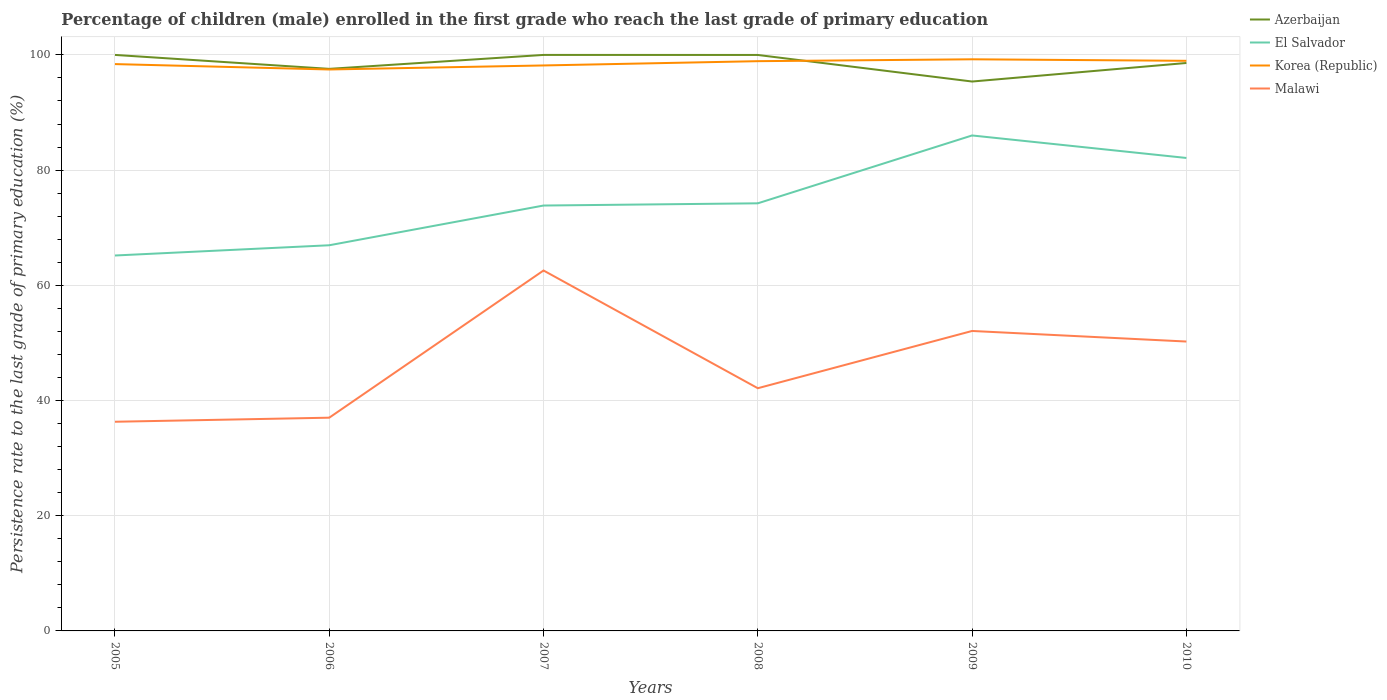How many different coloured lines are there?
Your answer should be very brief. 4. Does the line corresponding to El Salvador intersect with the line corresponding to Azerbaijan?
Provide a short and direct response. No. Across all years, what is the maximum persistence rate of children in El Salvador?
Your answer should be compact. 65.18. What is the total persistence rate of children in El Salvador in the graph?
Your response must be concise. -11.78. What is the difference between the highest and the second highest persistence rate of children in El Salvador?
Offer a very short reply. 20.84. Is the persistence rate of children in Korea (Republic) strictly greater than the persistence rate of children in Azerbaijan over the years?
Your answer should be compact. No. How many years are there in the graph?
Your response must be concise. 6. Are the values on the major ticks of Y-axis written in scientific E-notation?
Offer a terse response. No. Where does the legend appear in the graph?
Offer a very short reply. Top right. What is the title of the graph?
Provide a succinct answer. Percentage of children (male) enrolled in the first grade who reach the last grade of primary education. Does "Europe(all income levels)" appear as one of the legend labels in the graph?
Provide a short and direct response. No. What is the label or title of the Y-axis?
Provide a succinct answer. Persistence rate to the last grade of primary education (%). What is the Persistence rate to the last grade of primary education (%) in El Salvador in 2005?
Make the answer very short. 65.18. What is the Persistence rate to the last grade of primary education (%) of Korea (Republic) in 2005?
Offer a very short reply. 98.41. What is the Persistence rate to the last grade of primary education (%) in Malawi in 2005?
Offer a terse response. 36.31. What is the Persistence rate to the last grade of primary education (%) of Azerbaijan in 2006?
Your response must be concise. 97.58. What is the Persistence rate to the last grade of primary education (%) in El Salvador in 2006?
Give a very brief answer. 66.96. What is the Persistence rate to the last grade of primary education (%) in Korea (Republic) in 2006?
Offer a terse response. 97.47. What is the Persistence rate to the last grade of primary education (%) of Malawi in 2006?
Give a very brief answer. 37.02. What is the Persistence rate to the last grade of primary education (%) in Azerbaijan in 2007?
Provide a succinct answer. 100. What is the Persistence rate to the last grade of primary education (%) of El Salvador in 2007?
Ensure brevity in your answer.  73.85. What is the Persistence rate to the last grade of primary education (%) in Korea (Republic) in 2007?
Keep it short and to the point. 98.17. What is the Persistence rate to the last grade of primary education (%) in Malawi in 2007?
Provide a short and direct response. 62.57. What is the Persistence rate to the last grade of primary education (%) in Azerbaijan in 2008?
Give a very brief answer. 99.99. What is the Persistence rate to the last grade of primary education (%) of El Salvador in 2008?
Your answer should be compact. 74.24. What is the Persistence rate to the last grade of primary education (%) of Korea (Republic) in 2008?
Ensure brevity in your answer.  98.91. What is the Persistence rate to the last grade of primary education (%) in Malawi in 2008?
Make the answer very short. 42.13. What is the Persistence rate to the last grade of primary education (%) in Azerbaijan in 2009?
Your answer should be very brief. 95.38. What is the Persistence rate to the last grade of primary education (%) of El Salvador in 2009?
Give a very brief answer. 86.02. What is the Persistence rate to the last grade of primary education (%) of Korea (Republic) in 2009?
Provide a succinct answer. 99.24. What is the Persistence rate to the last grade of primary education (%) of Malawi in 2009?
Offer a very short reply. 52.08. What is the Persistence rate to the last grade of primary education (%) in Azerbaijan in 2010?
Offer a terse response. 98.6. What is the Persistence rate to the last grade of primary education (%) in El Salvador in 2010?
Your response must be concise. 82.11. What is the Persistence rate to the last grade of primary education (%) in Korea (Republic) in 2010?
Your response must be concise. 98.98. What is the Persistence rate to the last grade of primary education (%) of Malawi in 2010?
Provide a succinct answer. 50.24. Across all years, what is the maximum Persistence rate to the last grade of primary education (%) of Azerbaijan?
Your answer should be very brief. 100. Across all years, what is the maximum Persistence rate to the last grade of primary education (%) in El Salvador?
Ensure brevity in your answer.  86.02. Across all years, what is the maximum Persistence rate to the last grade of primary education (%) of Korea (Republic)?
Provide a short and direct response. 99.24. Across all years, what is the maximum Persistence rate to the last grade of primary education (%) in Malawi?
Keep it short and to the point. 62.57. Across all years, what is the minimum Persistence rate to the last grade of primary education (%) of Azerbaijan?
Ensure brevity in your answer.  95.38. Across all years, what is the minimum Persistence rate to the last grade of primary education (%) of El Salvador?
Make the answer very short. 65.18. Across all years, what is the minimum Persistence rate to the last grade of primary education (%) of Korea (Republic)?
Your answer should be very brief. 97.47. Across all years, what is the minimum Persistence rate to the last grade of primary education (%) in Malawi?
Give a very brief answer. 36.31. What is the total Persistence rate to the last grade of primary education (%) of Azerbaijan in the graph?
Your answer should be compact. 591.55. What is the total Persistence rate to the last grade of primary education (%) of El Salvador in the graph?
Your answer should be compact. 448.35. What is the total Persistence rate to the last grade of primary education (%) in Korea (Republic) in the graph?
Offer a terse response. 591.18. What is the total Persistence rate to the last grade of primary education (%) of Malawi in the graph?
Your answer should be compact. 280.36. What is the difference between the Persistence rate to the last grade of primary education (%) of Azerbaijan in 2005 and that in 2006?
Make the answer very short. 2.42. What is the difference between the Persistence rate to the last grade of primary education (%) in El Salvador in 2005 and that in 2006?
Keep it short and to the point. -1.78. What is the difference between the Persistence rate to the last grade of primary education (%) in Korea (Republic) in 2005 and that in 2006?
Make the answer very short. 0.94. What is the difference between the Persistence rate to the last grade of primary education (%) of Malawi in 2005 and that in 2006?
Your response must be concise. -0.71. What is the difference between the Persistence rate to the last grade of primary education (%) of Azerbaijan in 2005 and that in 2007?
Keep it short and to the point. 0. What is the difference between the Persistence rate to the last grade of primary education (%) of El Salvador in 2005 and that in 2007?
Give a very brief answer. -8.68. What is the difference between the Persistence rate to the last grade of primary education (%) of Korea (Republic) in 2005 and that in 2007?
Keep it short and to the point. 0.24. What is the difference between the Persistence rate to the last grade of primary education (%) of Malawi in 2005 and that in 2007?
Offer a very short reply. -26.26. What is the difference between the Persistence rate to the last grade of primary education (%) in Azerbaijan in 2005 and that in 2008?
Your response must be concise. 0.01. What is the difference between the Persistence rate to the last grade of primary education (%) of El Salvador in 2005 and that in 2008?
Give a very brief answer. -9.06. What is the difference between the Persistence rate to the last grade of primary education (%) of Korea (Republic) in 2005 and that in 2008?
Your answer should be very brief. -0.51. What is the difference between the Persistence rate to the last grade of primary education (%) in Malawi in 2005 and that in 2008?
Ensure brevity in your answer.  -5.82. What is the difference between the Persistence rate to the last grade of primary education (%) in Azerbaijan in 2005 and that in 2009?
Your answer should be very brief. 4.62. What is the difference between the Persistence rate to the last grade of primary education (%) of El Salvador in 2005 and that in 2009?
Offer a very short reply. -20.84. What is the difference between the Persistence rate to the last grade of primary education (%) in Korea (Republic) in 2005 and that in 2009?
Provide a short and direct response. -0.83. What is the difference between the Persistence rate to the last grade of primary education (%) in Malawi in 2005 and that in 2009?
Offer a very short reply. -15.76. What is the difference between the Persistence rate to the last grade of primary education (%) in Azerbaijan in 2005 and that in 2010?
Keep it short and to the point. 1.4. What is the difference between the Persistence rate to the last grade of primary education (%) of El Salvador in 2005 and that in 2010?
Provide a short and direct response. -16.93. What is the difference between the Persistence rate to the last grade of primary education (%) in Korea (Republic) in 2005 and that in 2010?
Offer a terse response. -0.57. What is the difference between the Persistence rate to the last grade of primary education (%) in Malawi in 2005 and that in 2010?
Ensure brevity in your answer.  -13.93. What is the difference between the Persistence rate to the last grade of primary education (%) in Azerbaijan in 2006 and that in 2007?
Your response must be concise. -2.42. What is the difference between the Persistence rate to the last grade of primary education (%) of El Salvador in 2006 and that in 2007?
Offer a terse response. -6.9. What is the difference between the Persistence rate to the last grade of primary education (%) of Korea (Republic) in 2006 and that in 2007?
Your response must be concise. -0.7. What is the difference between the Persistence rate to the last grade of primary education (%) of Malawi in 2006 and that in 2007?
Keep it short and to the point. -25.55. What is the difference between the Persistence rate to the last grade of primary education (%) of Azerbaijan in 2006 and that in 2008?
Your response must be concise. -2.41. What is the difference between the Persistence rate to the last grade of primary education (%) in El Salvador in 2006 and that in 2008?
Offer a terse response. -7.28. What is the difference between the Persistence rate to the last grade of primary education (%) of Korea (Republic) in 2006 and that in 2008?
Give a very brief answer. -1.44. What is the difference between the Persistence rate to the last grade of primary education (%) in Malawi in 2006 and that in 2008?
Keep it short and to the point. -5.11. What is the difference between the Persistence rate to the last grade of primary education (%) in El Salvador in 2006 and that in 2009?
Make the answer very short. -19.06. What is the difference between the Persistence rate to the last grade of primary education (%) of Korea (Republic) in 2006 and that in 2009?
Give a very brief answer. -1.77. What is the difference between the Persistence rate to the last grade of primary education (%) in Malawi in 2006 and that in 2009?
Make the answer very short. -15.06. What is the difference between the Persistence rate to the last grade of primary education (%) of Azerbaijan in 2006 and that in 2010?
Your response must be concise. -1.02. What is the difference between the Persistence rate to the last grade of primary education (%) of El Salvador in 2006 and that in 2010?
Provide a succinct answer. -15.16. What is the difference between the Persistence rate to the last grade of primary education (%) of Korea (Republic) in 2006 and that in 2010?
Keep it short and to the point. -1.5. What is the difference between the Persistence rate to the last grade of primary education (%) of Malawi in 2006 and that in 2010?
Provide a succinct answer. -13.22. What is the difference between the Persistence rate to the last grade of primary education (%) in Azerbaijan in 2007 and that in 2008?
Offer a terse response. 0.01. What is the difference between the Persistence rate to the last grade of primary education (%) of El Salvador in 2007 and that in 2008?
Provide a short and direct response. -0.38. What is the difference between the Persistence rate to the last grade of primary education (%) of Korea (Republic) in 2007 and that in 2008?
Ensure brevity in your answer.  -0.74. What is the difference between the Persistence rate to the last grade of primary education (%) of Malawi in 2007 and that in 2008?
Make the answer very short. 20.44. What is the difference between the Persistence rate to the last grade of primary education (%) in Azerbaijan in 2007 and that in 2009?
Ensure brevity in your answer.  4.62. What is the difference between the Persistence rate to the last grade of primary education (%) of El Salvador in 2007 and that in 2009?
Offer a very short reply. -12.16. What is the difference between the Persistence rate to the last grade of primary education (%) in Korea (Republic) in 2007 and that in 2009?
Your answer should be compact. -1.07. What is the difference between the Persistence rate to the last grade of primary education (%) of Malawi in 2007 and that in 2009?
Your answer should be very brief. 10.5. What is the difference between the Persistence rate to the last grade of primary education (%) of Azerbaijan in 2007 and that in 2010?
Your answer should be compact. 1.4. What is the difference between the Persistence rate to the last grade of primary education (%) in El Salvador in 2007 and that in 2010?
Provide a succinct answer. -8.26. What is the difference between the Persistence rate to the last grade of primary education (%) in Korea (Republic) in 2007 and that in 2010?
Make the answer very short. -0.81. What is the difference between the Persistence rate to the last grade of primary education (%) in Malawi in 2007 and that in 2010?
Provide a short and direct response. 12.33. What is the difference between the Persistence rate to the last grade of primary education (%) in Azerbaijan in 2008 and that in 2009?
Ensure brevity in your answer.  4.61. What is the difference between the Persistence rate to the last grade of primary education (%) of El Salvador in 2008 and that in 2009?
Your response must be concise. -11.78. What is the difference between the Persistence rate to the last grade of primary education (%) of Korea (Republic) in 2008 and that in 2009?
Your answer should be compact. -0.33. What is the difference between the Persistence rate to the last grade of primary education (%) in Malawi in 2008 and that in 2009?
Make the answer very short. -9.94. What is the difference between the Persistence rate to the last grade of primary education (%) in Azerbaijan in 2008 and that in 2010?
Provide a succinct answer. 1.39. What is the difference between the Persistence rate to the last grade of primary education (%) of El Salvador in 2008 and that in 2010?
Provide a succinct answer. -7.87. What is the difference between the Persistence rate to the last grade of primary education (%) of Korea (Republic) in 2008 and that in 2010?
Provide a short and direct response. -0.06. What is the difference between the Persistence rate to the last grade of primary education (%) of Malawi in 2008 and that in 2010?
Offer a terse response. -8.11. What is the difference between the Persistence rate to the last grade of primary education (%) in Azerbaijan in 2009 and that in 2010?
Make the answer very short. -3.22. What is the difference between the Persistence rate to the last grade of primary education (%) in El Salvador in 2009 and that in 2010?
Your answer should be compact. 3.91. What is the difference between the Persistence rate to the last grade of primary education (%) in Korea (Republic) in 2009 and that in 2010?
Provide a short and direct response. 0.26. What is the difference between the Persistence rate to the last grade of primary education (%) of Malawi in 2009 and that in 2010?
Provide a short and direct response. 1.84. What is the difference between the Persistence rate to the last grade of primary education (%) in Azerbaijan in 2005 and the Persistence rate to the last grade of primary education (%) in El Salvador in 2006?
Ensure brevity in your answer.  33.04. What is the difference between the Persistence rate to the last grade of primary education (%) in Azerbaijan in 2005 and the Persistence rate to the last grade of primary education (%) in Korea (Republic) in 2006?
Your answer should be very brief. 2.53. What is the difference between the Persistence rate to the last grade of primary education (%) of Azerbaijan in 2005 and the Persistence rate to the last grade of primary education (%) of Malawi in 2006?
Offer a very short reply. 62.98. What is the difference between the Persistence rate to the last grade of primary education (%) of El Salvador in 2005 and the Persistence rate to the last grade of primary education (%) of Korea (Republic) in 2006?
Keep it short and to the point. -32.3. What is the difference between the Persistence rate to the last grade of primary education (%) of El Salvador in 2005 and the Persistence rate to the last grade of primary education (%) of Malawi in 2006?
Provide a short and direct response. 28.16. What is the difference between the Persistence rate to the last grade of primary education (%) of Korea (Republic) in 2005 and the Persistence rate to the last grade of primary education (%) of Malawi in 2006?
Your answer should be compact. 61.39. What is the difference between the Persistence rate to the last grade of primary education (%) of Azerbaijan in 2005 and the Persistence rate to the last grade of primary education (%) of El Salvador in 2007?
Your answer should be compact. 26.15. What is the difference between the Persistence rate to the last grade of primary education (%) of Azerbaijan in 2005 and the Persistence rate to the last grade of primary education (%) of Korea (Republic) in 2007?
Ensure brevity in your answer.  1.83. What is the difference between the Persistence rate to the last grade of primary education (%) of Azerbaijan in 2005 and the Persistence rate to the last grade of primary education (%) of Malawi in 2007?
Offer a very short reply. 37.43. What is the difference between the Persistence rate to the last grade of primary education (%) in El Salvador in 2005 and the Persistence rate to the last grade of primary education (%) in Korea (Republic) in 2007?
Provide a short and direct response. -32.99. What is the difference between the Persistence rate to the last grade of primary education (%) in El Salvador in 2005 and the Persistence rate to the last grade of primary education (%) in Malawi in 2007?
Offer a very short reply. 2.6. What is the difference between the Persistence rate to the last grade of primary education (%) in Korea (Republic) in 2005 and the Persistence rate to the last grade of primary education (%) in Malawi in 2007?
Keep it short and to the point. 35.84. What is the difference between the Persistence rate to the last grade of primary education (%) of Azerbaijan in 2005 and the Persistence rate to the last grade of primary education (%) of El Salvador in 2008?
Your answer should be very brief. 25.76. What is the difference between the Persistence rate to the last grade of primary education (%) in Azerbaijan in 2005 and the Persistence rate to the last grade of primary education (%) in Korea (Republic) in 2008?
Your answer should be very brief. 1.09. What is the difference between the Persistence rate to the last grade of primary education (%) in Azerbaijan in 2005 and the Persistence rate to the last grade of primary education (%) in Malawi in 2008?
Your answer should be very brief. 57.87. What is the difference between the Persistence rate to the last grade of primary education (%) in El Salvador in 2005 and the Persistence rate to the last grade of primary education (%) in Korea (Republic) in 2008?
Give a very brief answer. -33.74. What is the difference between the Persistence rate to the last grade of primary education (%) of El Salvador in 2005 and the Persistence rate to the last grade of primary education (%) of Malawi in 2008?
Make the answer very short. 23.04. What is the difference between the Persistence rate to the last grade of primary education (%) of Korea (Republic) in 2005 and the Persistence rate to the last grade of primary education (%) of Malawi in 2008?
Make the answer very short. 56.27. What is the difference between the Persistence rate to the last grade of primary education (%) of Azerbaijan in 2005 and the Persistence rate to the last grade of primary education (%) of El Salvador in 2009?
Give a very brief answer. 13.98. What is the difference between the Persistence rate to the last grade of primary education (%) of Azerbaijan in 2005 and the Persistence rate to the last grade of primary education (%) of Korea (Republic) in 2009?
Your answer should be compact. 0.76. What is the difference between the Persistence rate to the last grade of primary education (%) of Azerbaijan in 2005 and the Persistence rate to the last grade of primary education (%) of Malawi in 2009?
Provide a short and direct response. 47.92. What is the difference between the Persistence rate to the last grade of primary education (%) in El Salvador in 2005 and the Persistence rate to the last grade of primary education (%) in Korea (Republic) in 2009?
Your answer should be very brief. -34.06. What is the difference between the Persistence rate to the last grade of primary education (%) of El Salvador in 2005 and the Persistence rate to the last grade of primary education (%) of Malawi in 2009?
Your answer should be very brief. 13.1. What is the difference between the Persistence rate to the last grade of primary education (%) in Korea (Republic) in 2005 and the Persistence rate to the last grade of primary education (%) in Malawi in 2009?
Your answer should be compact. 46.33. What is the difference between the Persistence rate to the last grade of primary education (%) in Azerbaijan in 2005 and the Persistence rate to the last grade of primary education (%) in El Salvador in 2010?
Your answer should be very brief. 17.89. What is the difference between the Persistence rate to the last grade of primary education (%) of Azerbaijan in 2005 and the Persistence rate to the last grade of primary education (%) of Korea (Republic) in 2010?
Your response must be concise. 1.02. What is the difference between the Persistence rate to the last grade of primary education (%) of Azerbaijan in 2005 and the Persistence rate to the last grade of primary education (%) of Malawi in 2010?
Your answer should be compact. 49.76. What is the difference between the Persistence rate to the last grade of primary education (%) of El Salvador in 2005 and the Persistence rate to the last grade of primary education (%) of Korea (Republic) in 2010?
Provide a succinct answer. -33.8. What is the difference between the Persistence rate to the last grade of primary education (%) of El Salvador in 2005 and the Persistence rate to the last grade of primary education (%) of Malawi in 2010?
Your response must be concise. 14.94. What is the difference between the Persistence rate to the last grade of primary education (%) in Korea (Republic) in 2005 and the Persistence rate to the last grade of primary education (%) in Malawi in 2010?
Offer a terse response. 48.17. What is the difference between the Persistence rate to the last grade of primary education (%) of Azerbaijan in 2006 and the Persistence rate to the last grade of primary education (%) of El Salvador in 2007?
Give a very brief answer. 23.73. What is the difference between the Persistence rate to the last grade of primary education (%) of Azerbaijan in 2006 and the Persistence rate to the last grade of primary education (%) of Korea (Republic) in 2007?
Provide a short and direct response. -0.59. What is the difference between the Persistence rate to the last grade of primary education (%) in Azerbaijan in 2006 and the Persistence rate to the last grade of primary education (%) in Malawi in 2007?
Ensure brevity in your answer.  35.01. What is the difference between the Persistence rate to the last grade of primary education (%) in El Salvador in 2006 and the Persistence rate to the last grade of primary education (%) in Korea (Republic) in 2007?
Offer a very short reply. -31.22. What is the difference between the Persistence rate to the last grade of primary education (%) of El Salvador in 2006 and the Persistence rate to the last grade of primary education (%) of Malawi in 2007?
Ensure brevity in your answer.  4.38. What is the difference between the Persistence rate to the last grade of primary education (%) in Korea (Republic) in 2006 and the Persistence rate to the last grade of primary education (%) in Malawi in 2007?
Your answer should be compact. 34.9. What is the difference between the Persistence rate to the last grade of primary education (%) of Azerbaijan in 2006 and the Persistence rate to the last grade of primary education (%) of El Salvador in 2008?
Keep it short and to the point. 23.34. What is the difference between the Persistence rate to the last grade of primary education (%) in Azerbaijan in 2006 and the Persistence rate to the last grade of primary education (%) in Korea (Republic) in 2008?
Your answer should be compact. -1.33. What is the difference between the Persistence rate to the last grade of primary education (%) in Azerbaijan in 2006 and the Persistence rate to the last grade of primary education (%) in Malawi in 2008?
Provide a succinct answer. 55.45. What is the difference between the Persistence rate to the last grade of primary education (%) in El Salvador in 2006 and the Persistence rate to the last grade of primary education (%) in Korea (Republic) in 2008?
Your answer should be compact. -31.96. What is the difference between the Persistence rate to the last grade of primary education (%) in El Salvador in 2006 and the Persistence rate to the last grade of primary education (%) in Malawi in 2008?
Offer a very short reply. 24.82. What is the difference between the Persistence rate to the last grade of primary education (%) in Korea (Republic) in 2006 and the Persistence rate to the last grade of primary education (%) in Malawi in 2008?
Your response must be concise. 55.34. What is the difference between the Persistence rate to the last grade of primary education (%) of Azerbaijan in 2006 and the Persistence rate to the last grade of primary education (%) of El Salvador in 2009?
Ensure brevity in your answer.  11.56. What is the difference between the Persistence rate to the last grade of primary education (%) in Azerbaijan in 2006 and the Persistence rate to the last grade of primary education (%) in Korea (Republic) in 2009?
Your answer should be compact. -1.66. What is the difference between the Persistence rate to the last grade of primary education (%) of Azerbaijan in 2006 and the Persistence rate to the last grade of primary education (%) of Malawi in 2009?
Your answer should be compact. 45.5. What is the difference between the Persistence rate to the last grade of primary education (%) in El Salvador in 2006 and the Persistence rate to the last grade of primary education (%) in Korea (Republic) in 2009?
Give a very brief answer. -32.29. What is the difference between the Persistence rate to the last grade of primary education (%) of El Salvador in 2006 and the Persistence rate to the last grade of primary education (%) of Malawi in 2009?
Give a very brief answer. 14.88. What is the difference between the Persistence rate to the last grade of primary education (%) of Korea (Republic) in 2006 and the Persistence rate to the last grade of primary education (%) of Malawi in 2009?
Provide a short and direct response. 45.4. What is the difference between the Persistence rate to the last grade of primary education (%) in Azerbaijan in 2006 and the Persistence rate to the last grade of primary education (%) in El Salvador in 2010?
Offer a terse response. 15.47. What is the difference between the Persistence rate to the last grade of primary education (%) in Azerbaijan in 2006 and the Persistence rate to the last grade of primary education (%) in Korea (Republic) in 2010?
Ensure brevity in your answer.  -1.4. What is the difference between the Persistence rate to the last grade of primary education (%) of Azerbaijan in 2006 and the Persistence rate to the last grade of primary education (%) of Malawi in 2010?
Your answer should be compact. 47.34. What is the difference between the Persistence rate to the last grade of primary education (%) in El Salvador in 2006 and the Persistence rate to the last grade of primary education (%) in Korea (Republic) in 2010?
Keep it short and to the point. -32.02. What is the difference between the Persistence rate to the last grade of primary education (%) in El Salvador in 2006 and the Persistence rate to the last grade of primary education (%) in Malawi in 2010?
Keep it short and to the point. 16.72. What is the difference between the Persistence rate to the last grade of primary education (%) in Korea (Republic) in 2006 and the Persistence rate to the last grade of primary education (%) in Malawi in 2010?
Make the answer very short. 47.23. What is the difference between the Persistence rate to the last grade of primary education (%) of Azerbaijan in 2007 and the Persistence rate to the last grade of primary education (%) of El Salvador in 2008?
Offer a terse response. 25.76. What is the difference between the Persistence rate to the last grade of primary education (%) in Azerbaijan in 2007 and the Persistence rate to the last grade of primary education (%) in Korea (Republic) in 2008?
Make the answer very short. 1.09. What is the difference between the Persistence rate to the last grade of primary education (%) of Azerbaijan in 2007 and the Persistence rate to the last grade of primary education (%) of Malawi in 2008?
Keep it short and to the point. 57.87. What is the difference between the Persistence rate to the last grade of primary education (%) in El Salvador in 2007 and the Persistence rate to the last grade of primary education (%) in Korea (Republic) in 2008?
Your answer should be very brief. -25.06. What is the difference between the Persistence rate to the last grade of primary education (%) in El Salvador in 2007 and the Persistence rate to the last grade of primary education (%) in Malawi in 2008?
Provide a short and direct response. 31.72. What is the difference between the Persistence rate to the last grade of primary education (%) in Korea (Republic) in 2007 and the Persistence rate to the last grade of primary education (%) in Malawi in 2008?
Your answer should be very brief. 56.04. What is the difference between the Persistence rate to the last grade of primary education (%) of Azerbaijan in 2007 and the Persistence rate to the last grade of primary education (%) of El Salvador in 2009?
Offer a terse response. 13.98. What is the difference between the Persistence rate to the last grade of primary education (%) in Azerbaijan in 2007 and the Persistence rate to the last grade of primary education (%) in Korea (Republic) in 2009?
Offer a terse response. 0.76. What is the difference between the Persistence rate to the last grade of primary education (%) in Azerbaijan in 2007 and the Persistence rate to the last grade of primary education (%) in Malawi in 2009?
Your response must be concise. 47.92. What is the difference between the Persistence rate to the last grade of primary education (%) in El Salvador in 2007 and the Persistence rate to the last grade of primary education (%) in Korea (Republic) in 2009?
Give a very brief answer. -25.39. What is the difference between the Persistence rate to the last grade of primary education (%) in El Salvador in 2007 and the Persistence rate to the last grade of primary education (%) in Malawi in 2009?
Make the answer very short. 21.78. What is the difference between the Persistence rate to the last grade of primary education (%) in Korea (Republic) in 2007 and the Persistence rate to the last grade of primary education (%) in Malawi in 2009?
Make the answer very short. 46.1. What is the difference between the Persistence rate to the last grade of primary education (%) of Azerbaijan in 2007 and the Persistence rate to the last grade of primary education (%) of El Salvador in 2010?
Offer a very short reply. 17.89. What is the difference between the Persistence rate to the last grade of primary education (%) of Azerbaijan in 2007 and the Persistence rate to the last grade of primary education (%) of Korea (Republic) in 2010?
Keep it short and to the point. 1.02. What is the difference between the Persistence rate to the last grade of primary education (%) in Azerbaijan in 2007 and the Persistence rate to the last grade of primary education (%) in Malawi in 2010?
Your answer should be compact. 49.76. What is the difference between the Persistence rate to the last grade of primary education (%) of El Salvador in 2007 and the Persistence rate to the last grade of primary education (%) of Korea (Republic) in 2010?
Offer a very short reply. -25.12. What is the difference between the Persistence rate to the last grade of primary education (%) in El Salvador in 2007 and the Persistence rate to the last grade of primary education (%) in Malawi in 2010?
Your response must be concise. 23.61. What is the difference between the Persistence rate to the last grade of primary education (%) of Korea (Republic) in 2007 and the Persistence rate to the last grade of primary education (%) of Malawi in 2010?
Offer a terse response. 47.93. What is the difference between the Persistence rate to the last grade of primary education (%) of Azerbaijan in 2008 and the Persistence rate to the last grade of primary education (%) of El Salvador in 2009?
Give a very brief answer. 13.98. What is the difference between the Persistence rate to the last grade of primary education (%) of Azerbaijan in 2008 and the Persistence rate to the last grade of primary education (%) of Korea (Republic) in 2009?
Offer a very short reply. 0.75. What is the difference between the Persistence rate to the last grade of primary education (%) of Azerbaijan in 2008 and the Persistence rate to the last grade of primary education (%) of Malawi in 2009?
Keep it short and to the point. 47.92. What is the difference between the Persistence rate to the last grade of primary education (%) in El Salvador in 2008 and the Persistence rate to the last grade of primary education (%) in Korea (Republic) in 2009?
Your answer should be very brief. -25. What is the difference between the Persistence rate to the last grade of primary education (%) in El Salvador in 2008 and the Persistence rate to the last grade of primary education (%) in Malawi in 2009?
Give a very brief answer. 22.16. What is the difference between the Persistence rate to the last grade of primary education (%) of Korea (Republic) in 2008 and the Persistence rate to the last grade of primary education (%) of Malawi in 2009?
Your response must be concise. 46.84. What is the difference between the Persistence rate to the last grade of primary education (%) of Azerbaijan in 2008 and the Persistence rate to the last grade of primary education (%) of El Salvador in 2010?
Provide a succinct answer. 17.88. What is the difference between the Persistence rate to the last grade of primary education (%) of Azerbaijan in 2008 and the Persistence rate to the last grade of primary education (%) of Korea (Republic) in 2010?
Ensure brevity in your answer.  1.02. What is the difference between the Persistence rate to the last grade of primary education (%) of Azerbaijan in 2008 and the Persistence rate to the last grade of primary education (%) of Malawi in 2010?
Your response must be concise. 49.75. What is the difference between the Persistence rate to the last grade of primary education (%) of El Salvador in 2008 and the Persistence rate to the last grade of primary education (%) of Korea (Republic) in 2010?
Keep it short and to the point. -24.74. What is the difference between the Persistence rate to the last grade of primary education (%) in El Salvador in 2008 and the Persistence rate to the last grade of primary education (%) in Malawi in 2010?
Offer a terse response. 24. What is the difference between the Persistence rate to the last grade of primary education (%) of Korea (Republic) in 2008 and the Persistence rate to the last grade of primary education (%) of Malawi in 2010?
Your answer should be compact. 48.67. What is the difference between the Persistence rate to the last grade of primary education (%) of Azerbaijan in 2009 and the Persistence rate to the last grade of primary education (%) of El Salvador in 2010?
Your response must be concise. 13.27. What is the difference between the Persistence rate to the last grade of primary education (%) in Azerbaijan in 2009 and the Persistence rate to the last grade of primary education (%) in Korea (Republic) in 2010?
Your answer should be compact. -3.6. What is the difference between the Persistence rate to the last grade of primary education (%) in Azerbaijan in 2009 and the Persistence rate to the last grade of primary education (%) in Malawi in 2010?
Your answer should be compact. 45.14. What is the difference between the Persistence rate to the last grade of primary education (%) of El Salvador in 2009 and the Persistence rate to the last grade of primary education (%) of Korea (Republic) in 2010?
Give a very brief answer. -12.96. What is the difference between the Persistence rate to the last grade of primary education (%) of El Salvador in 2009 and the Persistence rate to the last grade of primary education (%) of Malawi in 2010?
Make the answer very short. 35.78. What is the difference between the Persistence rate to the last grade of primary education (%) of Korea (Republic) in 2009 and the Persistence rate to the last grade of primary education (%) of Malawi in 2010?
Provide a succinct answer. 49. What is the average Persistence rate to the last grade of primary education (%) of Azerbaijan per year?
Ensure brevity in your answer.  98.59. What is the average Persistence rate to the last grade of primary education (%) in El Salvador per year?
Give a very brief answer. 74.72. What is the average Persistence rate to the last grade of primary education (%) in Korea (Republic) per year?
Offer a terse response. 98.53. What is the average Persistence rate to the last grade of primary education (%) in Malawi per year?
Your answer should be compact. 46.73. In the year 2005, what is the difference between the Persistence rate to the last grade of primary education (%) in Azerbaijan and Persistence rate to the last grade of primary education (%) in El Salvador?
Your response must be concise. 34.82. In the year 2005, what is the difference between the Persistence rate to the last grade of primary education (%) of Azerbaijan and Persistence rate to the last grade of primary education (%) of Korea (Republic)?
Provide a succinct answer. 1.59. In the year 2005, what is the difference between the Persistence rate to the last grade of primary education (%) of Azerbaijan and Persistence rate to the last grade of primary education (%) of Malawi?
Provide a succinct answer. 63.69. In the year 2005, what is the difference between the Persistence rate to the last grade of primary education (%) of El Salvador and Persistence rate to the last grade of primary education (%) of Korea (Republic)?
Offer a terse response. -33.23. In the year 2005, what is the difference between the Persistence rate to the last grade of primary education (%) of El Salvador and Persistence rate to the last grade of primary education (%) of Malawi?
Your answer should be compact. 28.86. In the year 2005, what is the difference between the Persistence rate to the last grade of primary education (%) in Korea (Republic) and Persistence rate to the last grade of primary education (%) in Malawi?
Your response must be concise. 62.09. In the year 2006, what is the difference between the Persistence rate to the last grade of primary education (%) in Azerbaijan and Persistence rate to the last grade of primary education (%) in El Salvador?
Keep it short and to the point. 30.62. In the year 2006, what is the difference between the Persistence rate to the last grade of primary education (%) in Azerbaijan and Persistence rate to the last grade of primary education (%) in Korea (Republic)?
Give a very brief answer. 0.11. In the year 2006, what is the difference between the Persistence rate to the last grade of primary education (%) of Azerbaijan and Persistence rate to the last grade of primary education (%) of Malawi?
Ensure brevity in your answer.  60.56. In the year 2006, what is the difference between the Persistence rate to the last grade of primary education (%) of El Salvador and Persistence rate to the last grade of primary education (%) of Korea (Republic)?
Make the answer very short. -30.52. In the year 2006, what is the difference between the Persistence rate to the last grade of primary education (%) of El Salvador and Persistence rate to the last grade of primary education (%) of Malawi?
Your answer should be very brief. 29.94. In the year 2006, what is the difference between the Persistence rate to the last grade of primary education (%) of Korea (Republic) and Persistence rate to the last grade of primary education (%) of Malawi?
Your answer should be compact. 60.45. In the year 2007, what is the difference between the Persistence rate to the last grade of primary education (%) in Azerbaijan and Persistence rate to the last grade of primary education (%) in El Salvador?
Provide a short and direct response. 26.15. In the year 2007, what is the difference between the Persistence rate to the last grade of primary education (%) of Azerbaijan and Persistence rate to the last grade of primary education (%) of Korea (Republic)?
Provide a short and direct response. 1.83. In the year 2007, what is the difference between the Persistence rate to the last grade of primary education (%) of Azerbaijan and Persistence rate to the last grade of primary education (%) of Malawi?
Provide a short and direct response. 37.43. In the year 2007, what is the difference between the Persistence rate to the last grade of primary education (%) in El Salvador and Persistence rate to the last grade of primary education (%) in Korea (Republic)?
Your response must be concise. -24.32. In the year 2007, what is the difference between the Persistence rate to the last grade of primary education (%) of El Salvador and Persistence rate to the last grade of primary education (%) of Malawi?
Your response must be concise. 11.28. In the year 2007, what is the difference between the Persistence rate to the last grade of primary education (%) of Korea (Republic) and Persistence rate to the last grade of primary education (%) of Malawi?
Offer a very short reply. 35.6. In the year 2008, what is the difference between the Persistence rate to the last grade of primary education (%) in Azerbaijan and Persistence rate to the last grade of primary education (%) in El Salvador?
Make the answer very short. 25.76. In the year 2008, what is the difference between the Persistence rate to the last grade of primary education (%) in Azerbaijan and Persistence rate to the last grade of primary education (%) in Korea (Republic)?
Provide a short and direct response. 1.08. In the year 2008, what is the difference between the Persistence rate to the last grade of primary education (%) in Azerbaijan and Persistence rate to the last grade of primary education (%) in Malawi?
Provide a succinct answer. 57.86. In the year 2008, what is the difference between the Persistence rate to the last grade of primary education (%) in El Salvador and Persistence rate to the last grade of primary education (%) in Korea (Republic)?
Offer a terse response. -24.68. In the year 2008, what is the difference between the Persistence rate to the last grade of primary education (%) of El Salvador and Persistence rate to the last grade of primary education (%) of Malawi?
Offer a terse response. 32.1. In the year 2008, what is the difference between the Persistence rate to the last grade of primary education (%) in Korea (Republic) and Persistence rate to the last grade of primary education (%) in Malawi?
Ensure brevity in your answer.  56.78. In the year 2009, what is the difference between the Persistence rate to the last grade of primary education (%) in Azerbaijan and Persistence rate to the last grade of primary education (%) in El Salvador?
Make the answer very short. 9.36. In the year 2009, what is the difference between the Persistence rate to the last grade of primary education (%) in Azerbaijan and Persistence rate to the last grade of primary education (%) in Korea (Republic)?
Make the answer very short. -3.86. In the year 2009, what is the difference between the Persistence rate to the last grade of primary education (%) of Azerbaijan and Persistence rate to the last grade of primary education (%) of Malawi?
Offer a terse response. 43.3. In the year 2009, what is the difference between the Persistence rate to the last grade of primary education (%) in El Salvador and Persistence rate to the last grade of primary education (%) in Korea (Republic)?
Your response must be concise. -13.22. In the year 2009, what is the difference between the Persistence rate to the last grade of primary education (%) of El Salvador and Persistence rate to the last grade of primary education (%) of Malawi?
Your response must be concise. 33.94. In the year 2009, what is the difference between the Persistence rate to the last grade of primary education (%) of Korea (Republic) and Persistence rate to the last grade of primary education (%) of Malawi?
Your answer should be compact. 47.17. In the year 2010, what is the difference between the Persistence rate to the last grade of primary education (%) of Azerbaijan and Persistence rate to the last grade of primary education (%) of El Salvador?
Offer a terse response. 16.49. In the year 2010, what is the difference between the Persistence rate to the last grade of primary education (%) in Azerbaijan and Persistence rate to the last grade of primary education (%) in Korea (Republic)?
Offer a terse response. -0.38. In the year 2010, what is the difference between the Persistence rate to the last grade of primary education (%) of Azerbaijan and Persistence rate to the last grade of primary education (%) of Malawi?
Your answer should be compact. 48.36. In the year 2010, what is the difference between the Persistence rate to the last grade of primary education (%) in El Salvador and Persistence rate to the last grade of primary education (%) in Korea (Republic)?
Keep it short and to the point. -16.87. In the year 2010, what is the difference between the Persistence rate to the last grade of primary education (%) in El Salvador and Persistence rate to the last grade of primary education (%) in Malawi?
Offer a terse response. 31.87. In the year 2010, what is the difference between the Persistence rate to the last grade of primary education (%) of Korea (Republic) and Persistence rate to the last grade of primary education (%) of Malawi?
Offer a very short reply. 48.74. What is the ratio of the Persistence rate to the last grade of primary education (%) in Azerbaijan in 2005 to that in 2006?
Provide a short and direct response. 1.02. What is the ratio of the Persistence rate to the last grade of primary education (%) in El Salvador in 2005 to that in 2006?
Make the answer very short. 0.97. What is the ratio of the Persistence rate to the last grade of primary education (%) in Korea (Republic) in 2005 to that in 2006?
Your answer should be very brief. 1.01. What is the ratio of the Persistence rate to the last grade of primary education (%) in Malawi in 2005 to that in 2006?
Your answer should be very brief. 0.98. What is the ratio of the Persistence rate to the last grade of primary education (%) of El Salvador in 2005 to that in 2007?
Ensure brevity in your answer.  0.88. What is the ratio of the Persistence rate to the last grade of primary education (%) of Malawi in 2005 to that in 2007?
Your answer should be compact. 0.58. What is the ratio of the Persistence rate to the last grade of primary education (%) in Azerbaijan in 2005 to that in 2008?
Your answer should be compact. 1. What is the ratio of the Persistence rate to the last grade of primary education (%) in El Salvador in 2005 to that in 2008?
Provide a short and direct response. 0.88. What is the ratio of the Persistence rate to the last grade of primary education (%) in Malawi in 2005 to that in 2008?
Provide a short and direct response. 0.86. What is the ratio of the Persistence rate to the last grade of primary education (%) of Azerbaijan in 2005 to that in 2009?
Give a very brief answer. 1.05. What is the ratio of the Persistence rate to the last grade of primary education (%) in El Salvador in 2005 to that in 2009?
Your answer should be very brief. 0.76. What is the ratio of the Persistence rate to the last grade of primary education (%) in Malawi in 2005 to that in 2009?
Keep it short and to the point. 0.7. What is the ratio of the Persistence rate to the last grade of primary education (%) of Azerbaijan in 2005 to that in 2010?
Offer a very short reply. 1.01. What is the ratio of the Persistence rate to the last grade of primary education (%) in El Salvador in 2005 to that in 2010?
Your answer should be compact. 0.79. What is the ratio of the Persistence rate to the last grade of primary education (%) of Malawi in 2005 to that in 2010?
Keep it short and to the point. 0.72. What is the ratio of the Persistence rate to the last grade of primary education (%) in Azerbaijan in 2006 to that in 2007?
Give a very brief answer. 0.98. What is the ratio of the Persistence rate to the last grade of primary education (%) in El Salvador in 2006 to that in 2007?
Give a very brief answer. 0.91. What is the ratio of the Persistence rate to the last grade of primary education (%) in Korea (Republic) in 2006 to that in 2007?
Offer a terse response. 0.99. What is the ratio of the Persistence rate to the last grade of primary education (%) of Malawi in 2006 to that in 2007?
Your answer should be very brief. 0.59. What is the ratio of the Persistence rate to the last grade of primary education (%) of Azerbaijan in 2006 to that in 2008?
Your answer should be very brief. 0.98. What is the ratio of the Persistence rate to the last grade of primary education (%) in El Salvador in 2006 to that in 2008?
Your answer should be compact. 0.9. What is the ratio of the Persistence rate to the last grade of primary education (%) of Korea (Republic) in 2006 to that in 2008?
Provide a short and direct response. 0.99. What is the ratio of the Persistence rate to the last grade of primary education (%) in Malawi in 2006 to that in 2008?
Your response must be concise. 0.88. What is the ratio of the Persistence rate to the last grade of primary education (%) in Azerbaijan in 2006 to that in 2009?
Provide a short and direct response. 1.02. What is the ratio of the Persistence rate to the last grade of primary education (%) of El Salvador in 2006 to that in 2009?
Offer a very short reply. 0.78. What is the ratio of the Persistence rate to the last grade of primary education (%) in Korea (Republic) in 2006 to that in 2009?
Your response must be concise. 0.98. What is the ratio of the Persistence rate to the last grade of primary education (%) in Malawi in 2006 to that in 2009?
Your response must be concise. 0.71. What is the ratio of the Persistence rate to the last grade of primary education (%) in Azerbaijan in 2006 to that in 2010?
Keep it short and to the point. 0.99. What is the ratio of the Persistence rate to the last grade of primary education (%) in El Salvador in 2006 to that in 2010?
Your answer should be very brief. 0.82. What is the ratio of the Persistence rate to the last grade of primary education (%) in Korea (Republic) in 2006 to that in 2010?
Ensure brevity in your answer.  0.98. What is the ratio of the Persistence rate to the last grade of primary education (%) of Malawi in 2006 to that in 2010?
Keep it short and to the point. 0.74. What is the ratio of the Persistence rate to the last grade of primary education (%) in El Salvador in 2007 to that in 2008?
Provide a succinct answer. 0.99. What is the ratio of the Persistence rate to the last grade of primary education (%) in Malawi in 2007 to that in 2008?
Provide a short and direct response. 1.49. What is the ratio of the Persistence rate to the last grade of primary education (%) of Azerbaijan in 2007 to that in 2009?
Ensure brevity in your answer.  1.05. What is the ratio of the Persistence rate to the last grade of primary education (%) in El Salvador in 2007 to that in 2009?
Provide a short and direct response. 0.86. What is the ratio of the Persistence rate to the last grade of primary education (%) of Korea (Republic) in 2007 to that in 2009?
Offer a very short reply. 0.99. What is the ratio of the Persistence rate to the last grade of primary education (%) of Malawi in 2007 to that in 2009?
Your answer should be compact. 1.2. What is the ratio of the Persistence rate to the last grade of primary education (%) of Azerbaijan in 2007 to that in 2010?
Ensure brevity in your answer.  1.01. What is the ratio of the Persistence rate to the last grade of primary education (%) of El Salvador in 2007 to that in 2010?
Ensure brevity in your answer.  0.9. What is the ratio of the Persistence rate to the last grade of primary education (%) in Korea (Republic) in 2007 to that in 2010?
Provide a succinct answer. 0.99. What is the ratio of the Persistence rate to the last grade of primary education (%) of Malawi in 2007 to that in 2010?
Give a very brief answer. 1.25. What is the ratio of the Persistence rate to the last grade of primary education (%) of Azerbaijan in 2008 to that in 2009?
Offer a very short reply. 1.05. What is the ratio of the Persistence rate to the last grade of primary education (%) in El Salvador in 2008 to that in 2009?
Give a very brief answer. 0.86. What is the ratio of the Persistence rate to the last grade of primary education (%) in Malawi in 2008 to that in 2009?
Provide a succinct answer. 0.81. What is the ratio of the Persistence rate to the last grade of primary education (%) in Azerbaijan in 2008 to that in 2010?
Ensure brevity in your answer.  1.01. What is the ratio of the Persistence rate to the last grade of primary education (%) in El Salvador in 2008 to that in 2010?
Make the answer very short. 0.9. What is the ratio of the Persistence rate to the last grade of primary education (%) in Korea (Republic) in 2008 to that in 2010?
Your answer should be compact. 1. What is the ratio of the Persistence rate to the last grade of primary education (%) of Malawi in 2008 to that in 2010?
Provide a succinct answer. 0.84. What is the ratio of the Persistence rate to the last grade of primary education (%) in Azerbaijan in 2009 to that in 2010?
Provide a short and direct response. 0.97. What is the ratio of the Persistence rate to the last grade of primary education (%) in El Salvador in 2009 to that in 2010?
Provide a succinct answer. 1.05. What is the ratio of the Persistence rate to the last grade of primary education (%) of Malawi in 2009 to that in 2010?
Offer a very short reply. 1.04. What is the difference between the highest and the second highest Persistence rate to the last grade of primary education (%) of El Salvador?
Provide a short and direct response. 3.91. What is the difference between the highest and the second highest Persistence rate to the last grade of primary education (%) in Korea (Republic)?
Provide a short and direct response. 0.26. What is the difference between the highest and the second highest Persistence rate to the last grade of primary education (%) in Malawi?
Offer a terse response. 10.5. What is the difference between the highest and the lowest Persistence rate to the last grade of primary education (%) of Azerbaijan?
Make the answer very short. 4.62. What is the difference between the highest and the lowest Persistence rate to the last grade of primary education (%) of El Salvador?
Keep it short and to the point. 20.84. What is the difference between the highest and the lowest Persistence rate to the last grade of primary education (%) in Korea (Republic)?
Keep it short and to the point. 1.77. What is the difference between the highest and the lowest Persistence rate to the last grade of primary education (%) of Malawi?
Your answer should be compact. 26.26. 